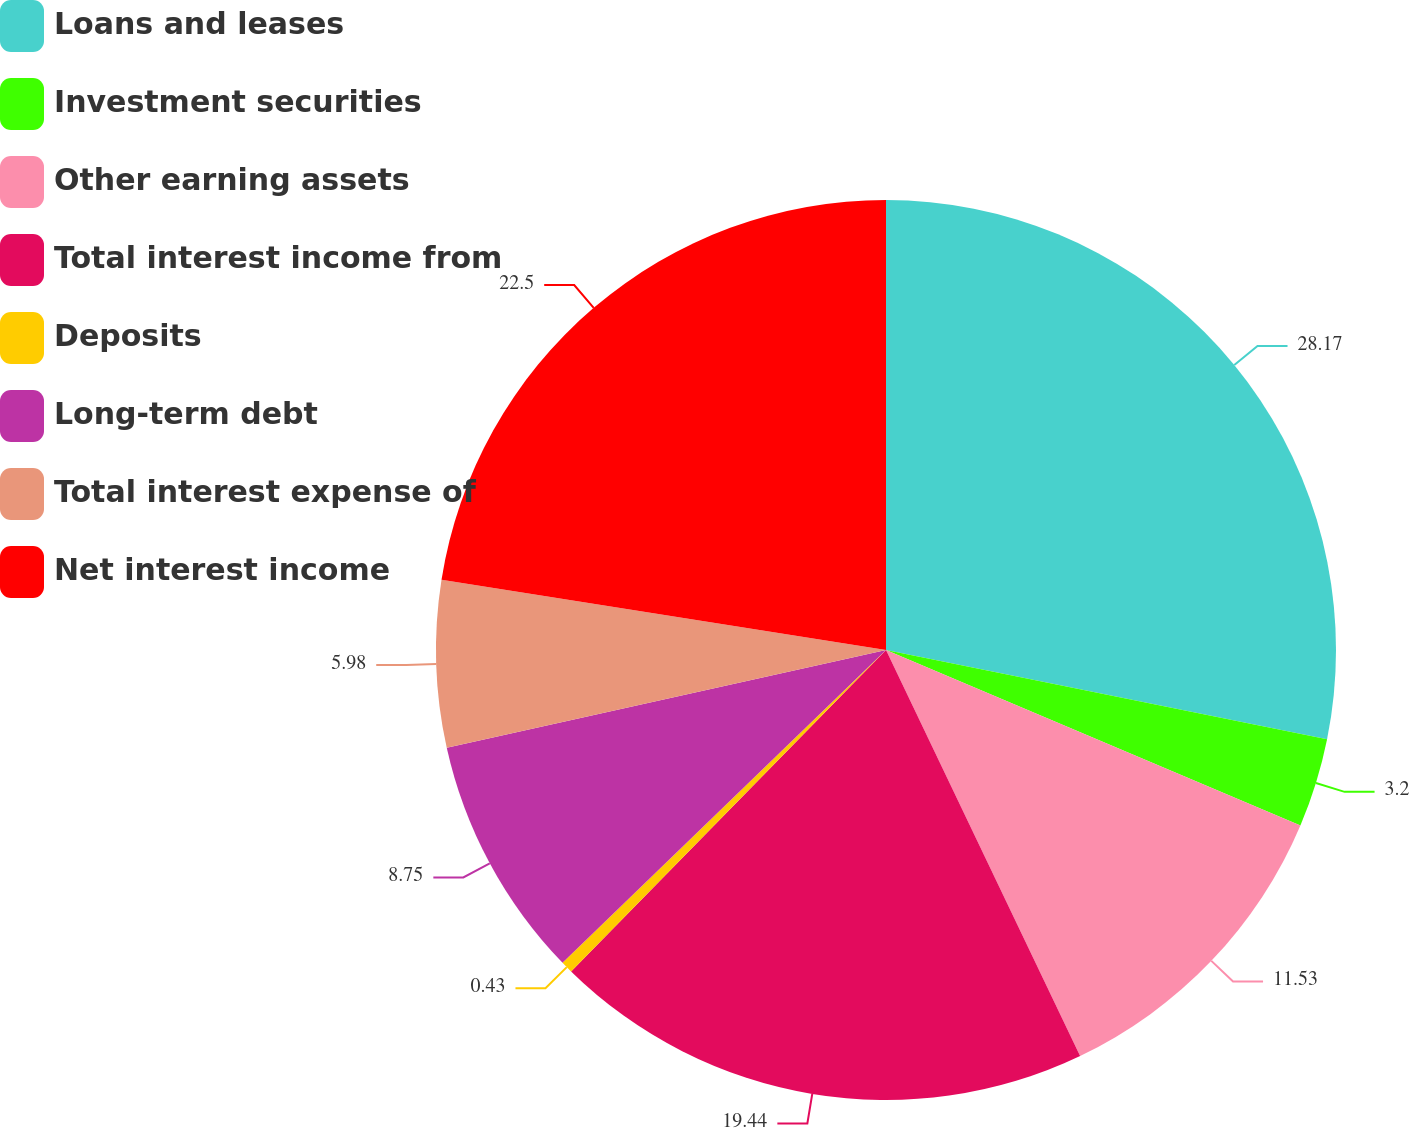Convert chart to OTSL. <chart><loc_0><loc_0><loc_500><loc_500><pie_chart><fcel>Loans and leases<fcel>Investment securities<fcel>Other earning assets<fcel>Total interest income from<fcel>Deposits<fcel>Long-term debt<fcel>Total interest expense of<fcel>Net interest income<nl><fcel>28.18%<fcel>3.2%<fcel>11.53%<fcel>19.44%<fcel>0.43%<fcel>8.75%<fcel>5.98%<fcel>22.51%<nl></chart> 